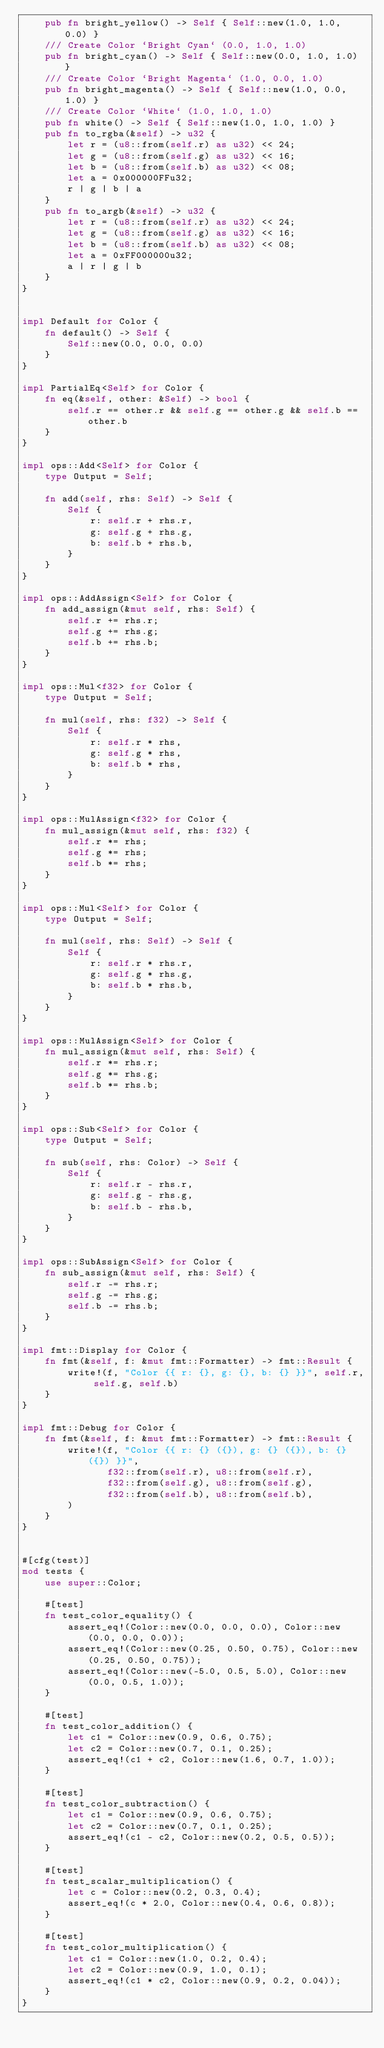Convert code to text. <code><loc_0><loc_0><loc_500><loc_500><_Rust_>    pub fn bright_yellow() -> Self { Self::new(1.0, 1.0, 0.0) }
    /// Create Color `Bright Cyan` (0.0, 1.0, 1.0)
    pub fn bright_cyan() -> Self { Self::new(0.0, 1.0, 1.0) }
    /// Create Color `Bright Magenta` (1.0, 0.0, 1.0)
    pub fn bright_magenta() -> Self { Self::new(1.0, 0.0, 1.0) }
    /// Create Color `White` (1.0, 1.0, 1.0)
    pub fn white() -> Self { Self::new(1.0, 1.0, 1.0) }
    pub fn to_rgba(&self) -> u32 {
        let r = (u8::from(self.r) as u32) << 24;
        let g = (u8::from(self.g) as u32) << 16;
        let b = (u8::from(self.b) as u32) << 08;
        let a = 0x000000FFu32;
        r | g | b | a
    }
    pub fn to_argb(&self) -> u32 {
        let r = (u8::from(self.r) as u32) << 24;
        let g = (u8::from(self.g) as u32) << 16;
        let b = (u8::from(self.b) as u32) << 08;
        let a = 0xFF000000u32;
        a | r | g | b
    }
}


impl Default for Color {
    fn default() -> Self {
        Self::new(0.0, 0.0, 0.0)
    }
}

impl PartialEq<Self> for Color {
    fn eq(&self, other: &Self) -> bool {
        self.r == other.r && self.g == other.g && self.b == other.b
    }
}

impl ops::Add<Self> for Color {
    type Output = Self;

    fn add(self, rhs: Self) -> Self {
        Self {
            r: self.r + rhs.r,
            g: self.g + rhs.g,
            b: self.b + rhs.b,
        }
    }
}

impl ops::AddAssign<Self> for Color {
    fn add_assign(&mut self, rhs: Self) {
        self.r += rhs.r;
        self.g += rhs.g;
        self.b += rhs.b;
    }
}

impl ops::Mul<f32> for Color {
    type Output = Self;

    fn mul(self, rhs: f32) -> Self {
        Self {
            r: self.r * rhs,
            g: self.g * rhs,
            b: self.b * rhs,
        }
    }
}

impl ops::MulAssign<f32> for Color {
    fn mul_assign(&mut self, rhs: f32) {
        self.r *= rhs;
        self.g *= rhs;
        self.b *= rhs;
    }
}

impl ops::Mul<Self> for Color {
    type Output = Self;

    fn mul(self, rhs: Self) -> Self {
        Self {
            r: self.r * rhs.r,
            g: self.g * rhs.g,
            b: self.b * rhs.b,
        }
    }
}

impl ops::MulAssign<Self> for Color {
    fn mul_assign(&mut self, rhs: Self) {
        self.r *= rhs.r;
        self.g *= rhs.g;
        self.b *= rhs.b;
    }
}

impl ops::Sub<Self> for Color {
    type Output = Self;

    fn sub(self, rhs: Color) -> Self {
        Self {
            r: self.r - rhs.r,
            g: self.g - rhs.g,
            b: self.b - rhs.b,
        }
    }
}

impl ops::SubAssign<Self> for Color {
    fn sub_assign(&mut self, rhs: Self) {
        self.r -= rhs.r;
        self.g -= rhs.g;
        self.b -= rhs.b;
    }
}

impl fmt::Display for Color {
    fn fmt(&self, f: &mut fmt::Formatter) -> fmt::Result {
        write!(f, "Color {{ r: {}, g: {}, b: {} }}", self.r, self.g, self.b)
    }
}

impl fmt::Debug for Color {
    fn fmt(&self, f: &mut fmt::Formatter) -> fmt::Result {
        write!(f, "Color {{ r: {} ({}), g: {} ({}), b: {} ({}) }}",
               f32::from(self.r), u8::from(self.r),
               f32::from(self.g), u8::from(self.g),
               f32::from(self.b), u8::from(self.b),
        )
    }
}


#[cfg(test)]
mod tests {
    use super::Color;

    #[test]
    fn test_color_equality() {
        assert_eq!(Color::new(0.0, 0.0, 0.0), Color::new(0.0, 0.0, 0.0));
        assert_eq!(Color::new(0.25, 0.50, 0.75), Color::new(0.25, 0.50, 0.75));
        assert_eq!(Color::new(-5.0, 0.5, 5.0), Color::new(0.0, 0.5, 1.0));
    }

    #[test]
    fn test_color_addition() {
        let c1 = Color::new(0.9, 0.6, 0.75);
        let c2 = Color::new(0.7, 0.1, 0.25);
        assert_eq!(c1 + c2, Color::new(1.6, 0.7, 1.0));
    }

    #[test]
    fn test_color_subtraction() {
        let c1 = Color::new(0.9, 0.6, 0.75);
        let c2 = Color::new(0.7, 0.1, 0.25);
        assert_eq!(c1 - c2, Color::new(0.2, 0.5, 0.5));
    }

    #[test]
    fn test_scalar_multiplication() {
        let c = Color::new(0.2, 0.3, 0.4);
        assert_eq!(c * 2.0, Color::new(0.4, 0.6, 0.8));
    }

    #[test]
    fn test_color_multiplication() {
        let c1 = Color::new(1.0, 0.2, 0.4);
        let c2 = Color::new(0.9, 1.0, 0.1);
        assert_eq!(c1 * c2, Color::new(0.9, 0.2, 0.04));
    }
}</code> 